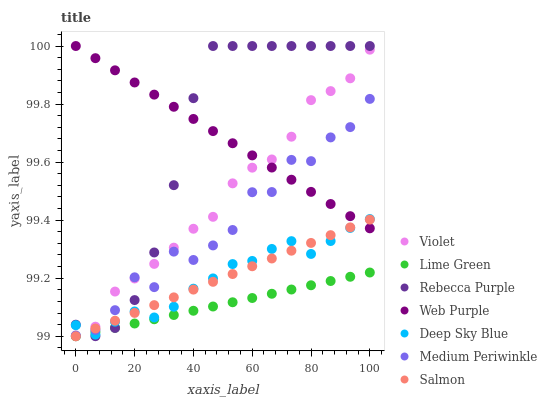Does Lime Green have the minimum area under the curve?
Answer yes or no. Yes. Does Rebecca Purple have the maximum area under the curve?
Answer yes or no. Yes. Does Medium Periwinkle have the minimum area under the curve?
Answer yes or no. No. Does Medium Periwinkle have the maximum area under the curve?
Answer yes or no. No. Is Web Purple the smoothest?
Answer yes or no. Yes. Is Medium Periwinkle the roughest?
Answer yes or no. Yes. Is Medium Periwinkle the smoothest?
Answer yes or no. No. Is Web Purple the roughest?
Answer yes or no. No. Does Salmon have the lowest value?
Answer yes or no. Yes. Does Medium Periwinkle have the lowest value?
Answer yes or no. No. Does Rebecca Purple have the highest value?
Answer yes or no. Yes. Does Medium Periwinkle have the highest value?
Answer yes or no. No. Is Lime Green less than Web Purple?
Answer yes or no. Yes. Is Medium Periwinkle greater than Lime Green?
Answer yes or no. Yes. Does Violet intersect Web Purple?
Answer yes or no. Yes. Is Violet less than Web Purple?
Answer yes or no. No. Is Violet greater than Web Purple?
Answer yes or no. No. Does Lime Green intersect Web Purple?
Answer yes or no. No. 